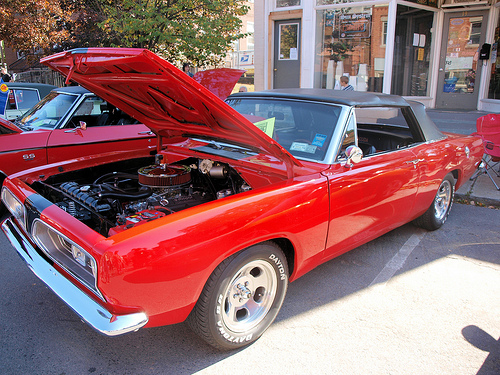<image>
Can you confirm if the car is behind the store? No. The car is not behind the store. From this viewpoint, the car appears to be positioned elsewhere in the scene. 